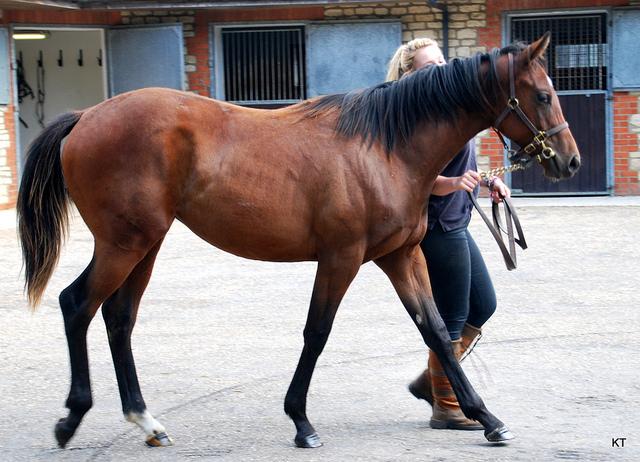Who is walking the horse?
Write a very short answer. Lady. Is the horse looking at the camera?
Give a very brief answer. No. What color is the horse?
Write a very short answer. Brown. How many horses are there?
Be succinct. 1. 